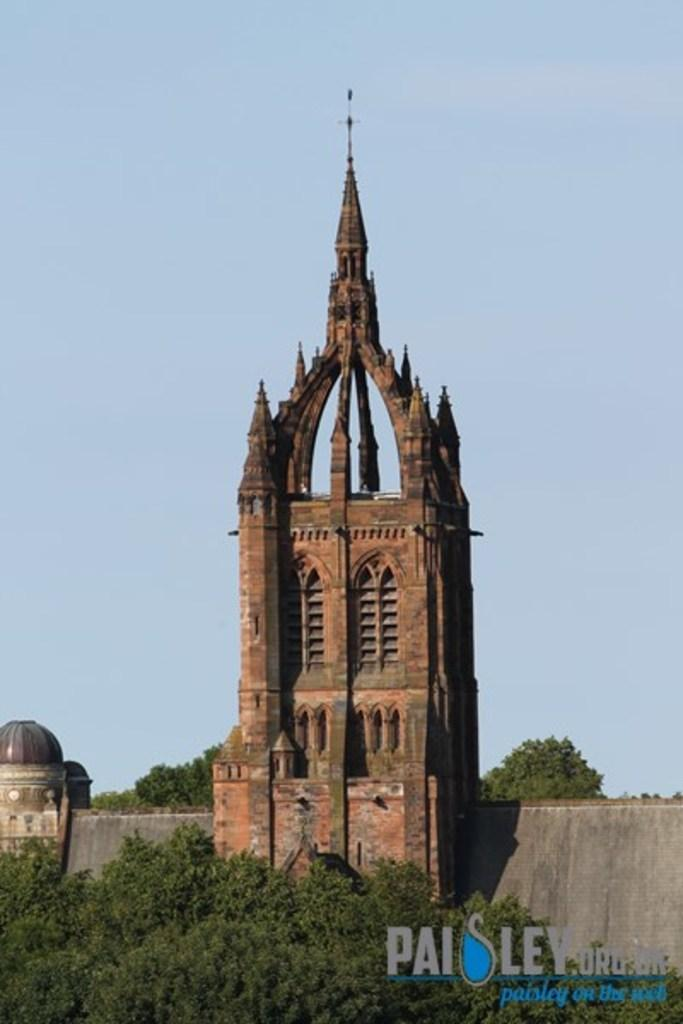What type of structures can be seen in the image? There are buildings in the image. What other elements are present in the image besides buildings? There are trees in the image. Is there any text visible in the image? Yes, there is some text in the bottom right-hand corner of the image. How many snails can be seen crawling on the buildings in the image? There are no snails present in the image; it only features buildings and trees. What type of pet is visible in the image? There is no pet visible in the image. 